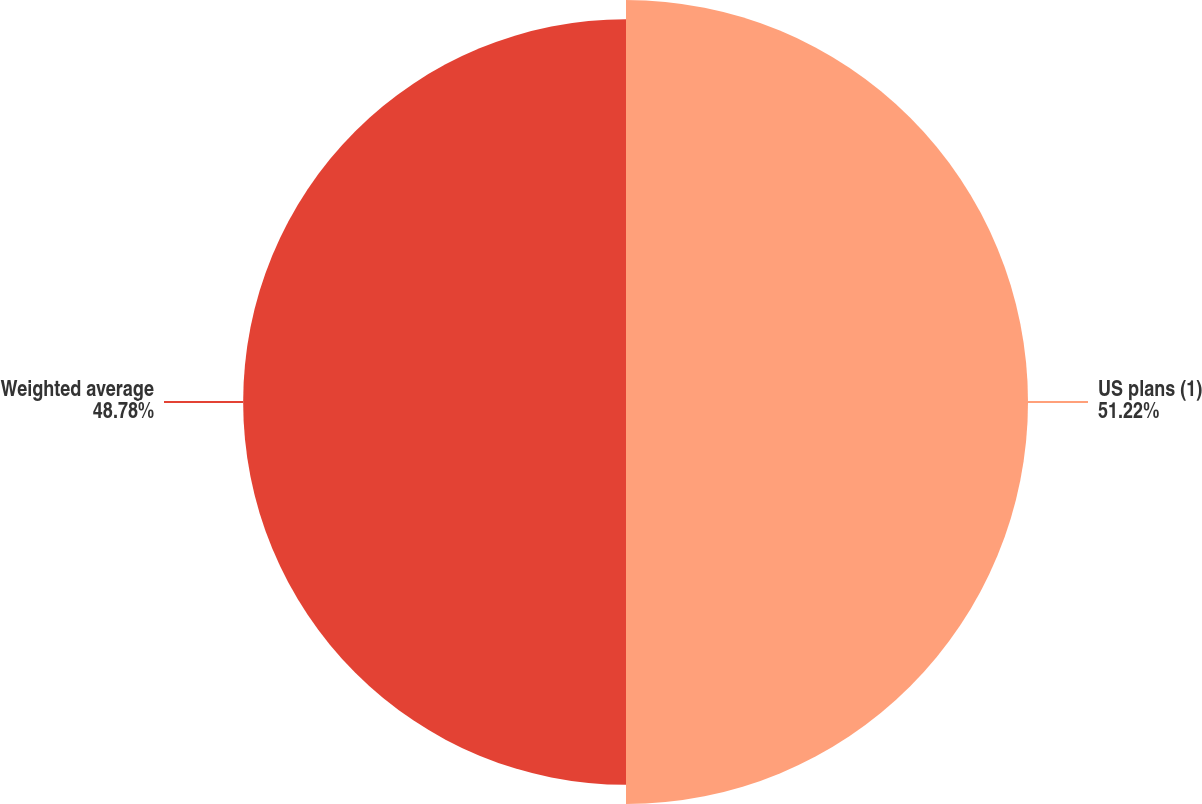<chart> <loc_0><loc_0><loc_500><loc_500><pie_chart><fcel>US plans (1)<fcel>Weighted average<nl><fcel>51.22%<fcel>48.78%<nl></chart> 